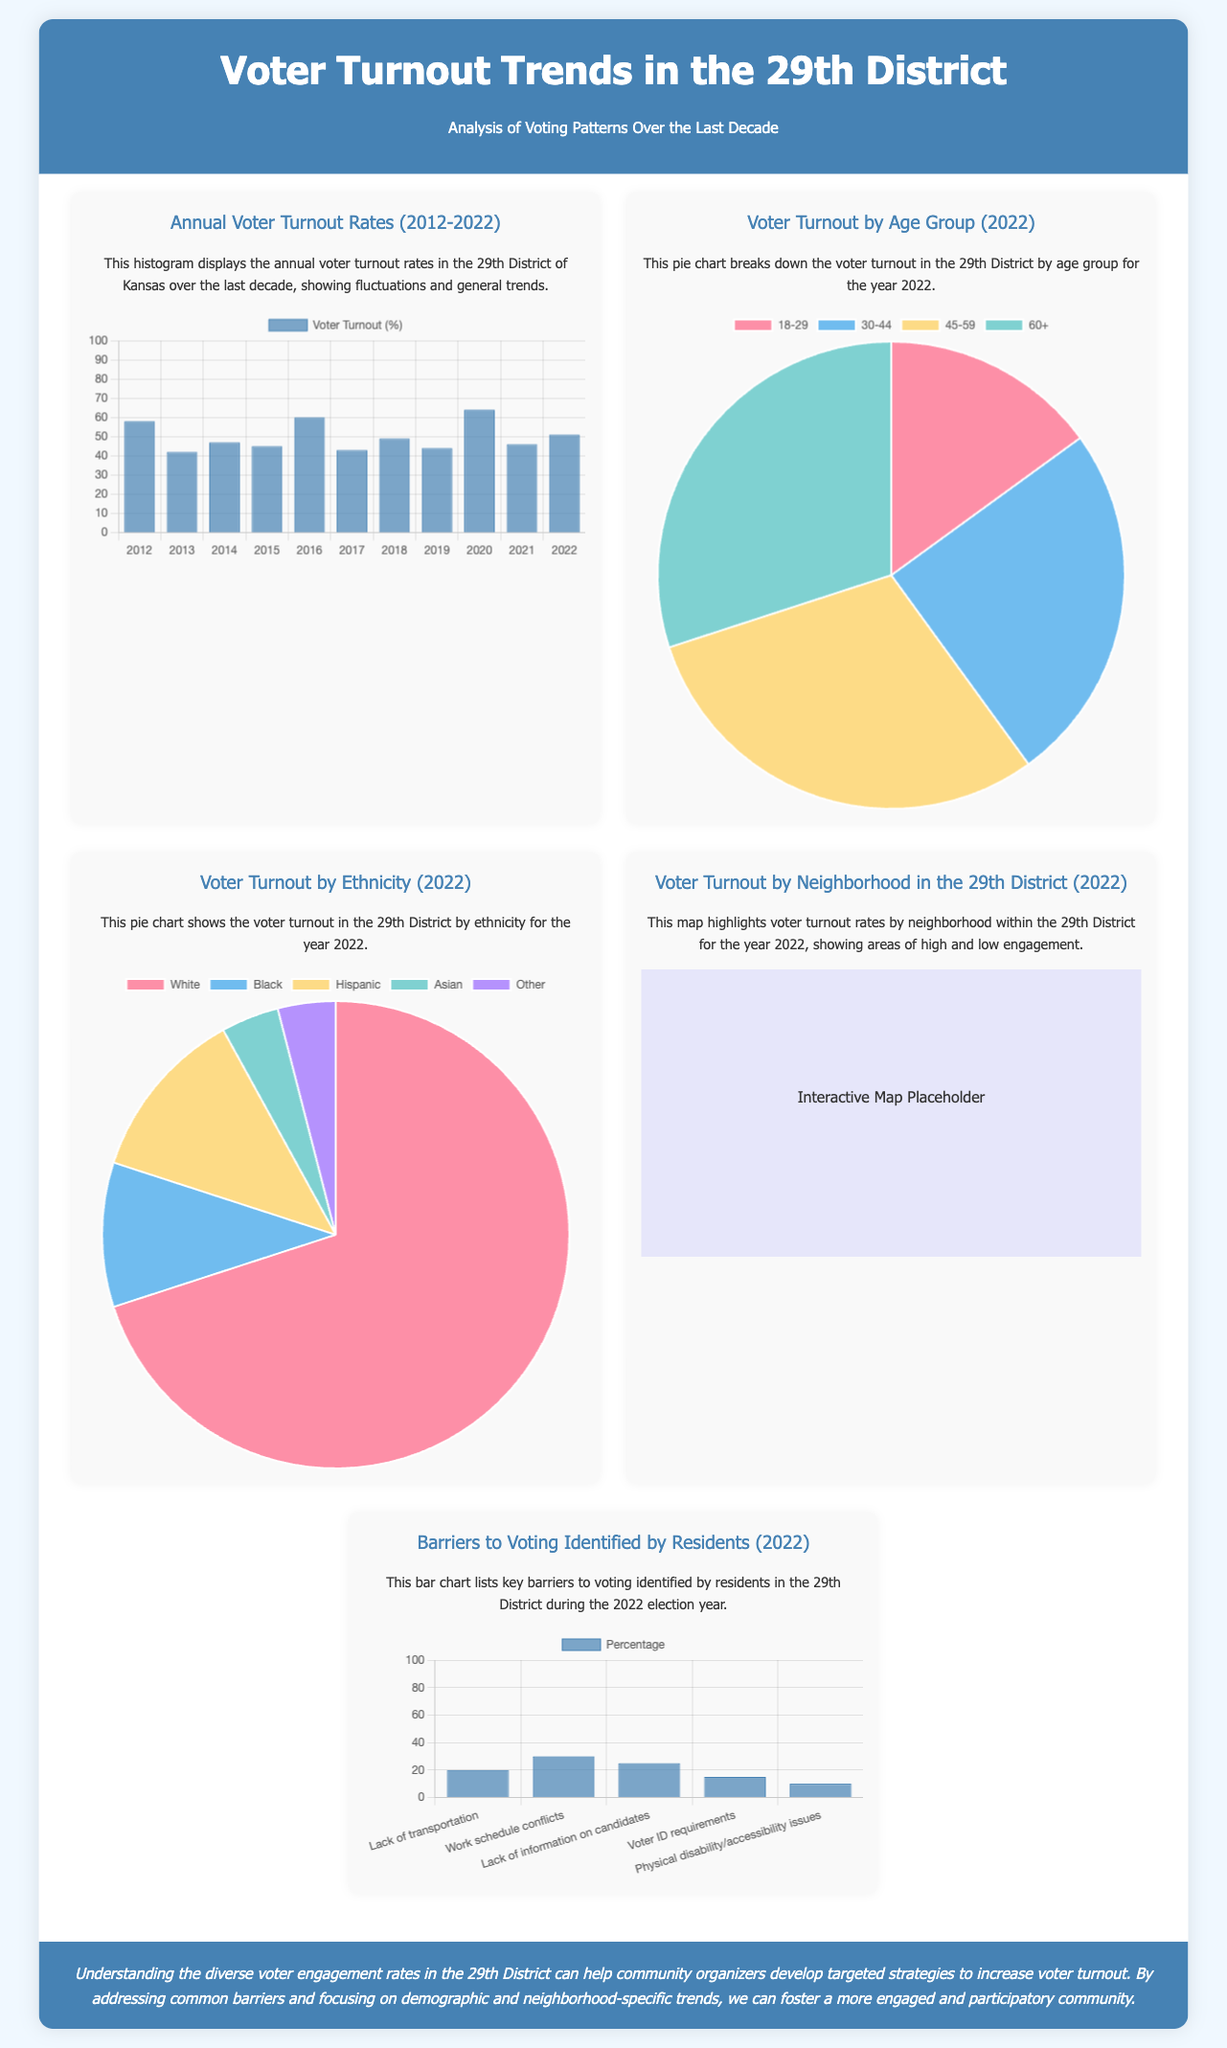What was the voter turnout rate in 2020? The voter turnout rate in 2020 is 64%, as shown in the annual voter turnout rates histogram.
Answer: 64% Which age group had the highest voter turnout in 2022? The age group with the highest voter turnout in 2022 is 45-59, as indicated in the pie chart for voter turnout by age group.
Answer: 45-59 How many percentage points did voter turnout increase from 2019 to 2020? The increase in voter turnout from 2019 (44%) to 2020 (64%) is calculated as 64% - 44% = 20%.
Answer: 20% What percentage of voters identified lack of transportation as a barrier in 2022? The percentage of voters identifying lack of transportation as a barrier is 20%, represented in the barriers to voting chart.
Answer: 20% What demographic had the lowest percentage of voter turnout in 2022? The demographic with the lowest percentage of voter turnout in 2022 is Asian, as depicted in the pie chart for voter turnout by ethnicity.
Answer: Asian How many years does the histogram cover for annual voter turnout rates? The histogram covers 11 years, from 2012 to 2022.
Answer: 11 years Which neighborhood in the 29th District had the highest voter engagement in 2022? The specific neighborhood with the highest engagement is not detailed in the document but is indicated in the map showing voter turnout by neighborhood.
Answer: Not specified What was the percentage of Black voters in the 2022 election? The percentage of Black voters in the 2022 election is 10%, shown in the pie chart for voter turnout by ethnicity.
Answer: 10% What is the significance of understanding diverse voter engagement rates? Understanding diverse voter engagement rates is important for community organizers to develop targeted strategies to increase turnout.
Answer: Targeted strategies 